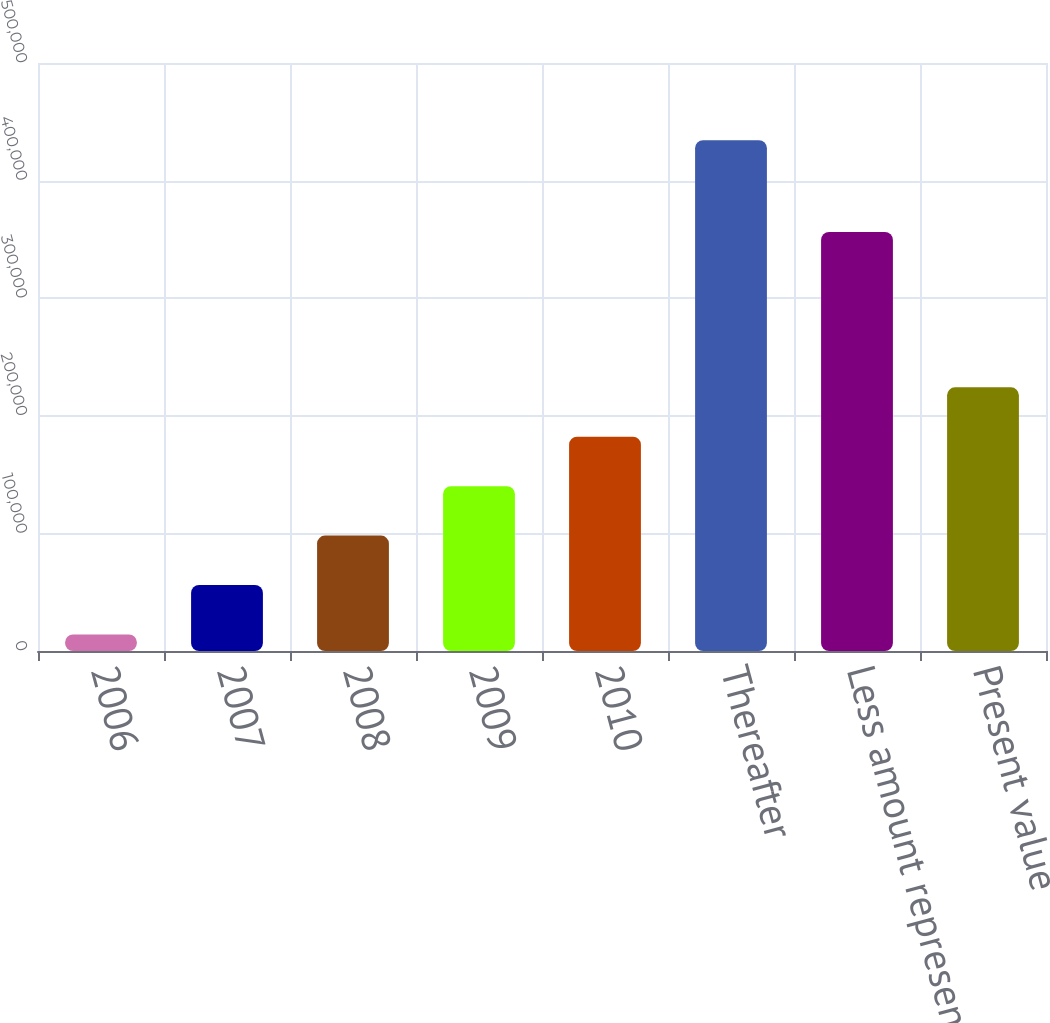Convert chart. <chart><loc_0><loc_0><loc_500><loc_500><bar_chart><fcel>2006<fcel>2007<fcel>2008<fcel>2009<fcel>2010<fcel>Thereafter<fcel>Less amount representing<fcel>Present value<nl><fcel>14104<fcel>56126.4<fcel>98148.8<fcel>140171<fcel>182194<fcel>434328<fcel>356301<fcel>224216<nl></chart> 